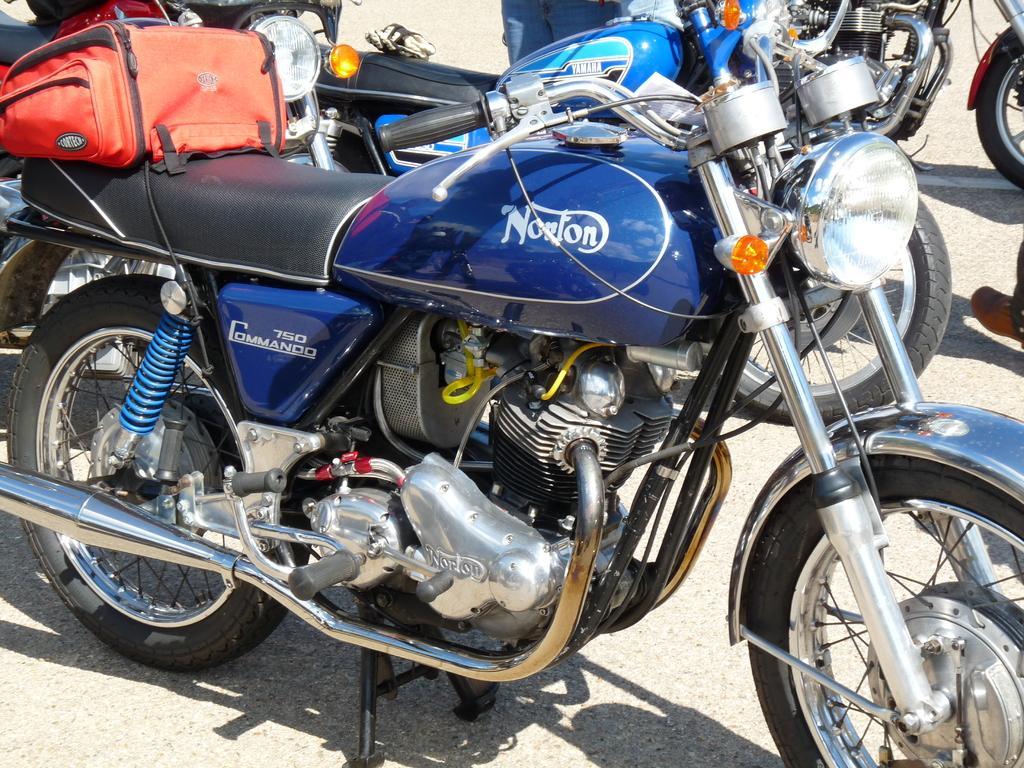How would you summarize this image in a sentence or two? In this image we can see a blue color motorbike with a bag on it. In the background, we can see a few more motorbikes. 